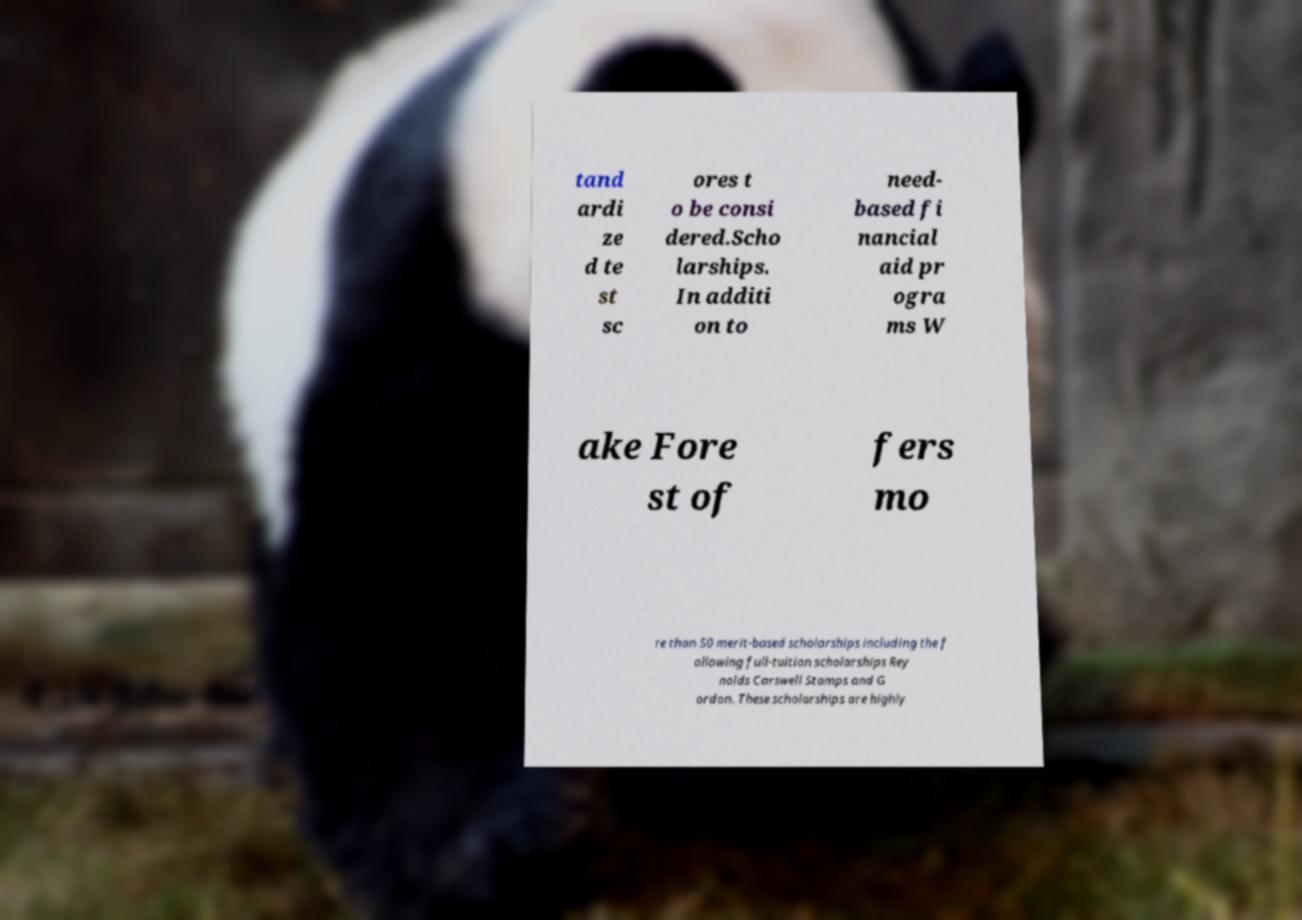There's text embedded in this image that I need extracted. Can you transcribe it verbatim? tand ardi ze d te st sc ores t o be consi dered.Scho larships. In additi on to need- based fi nancial aid pr ogra ms W ake Fore st of fers mo re than 50 merit-based scholarships including the f ollowing full-tuition scholarships Rey nolds Carswell Stamps and G ordon. These scholarships are highly 